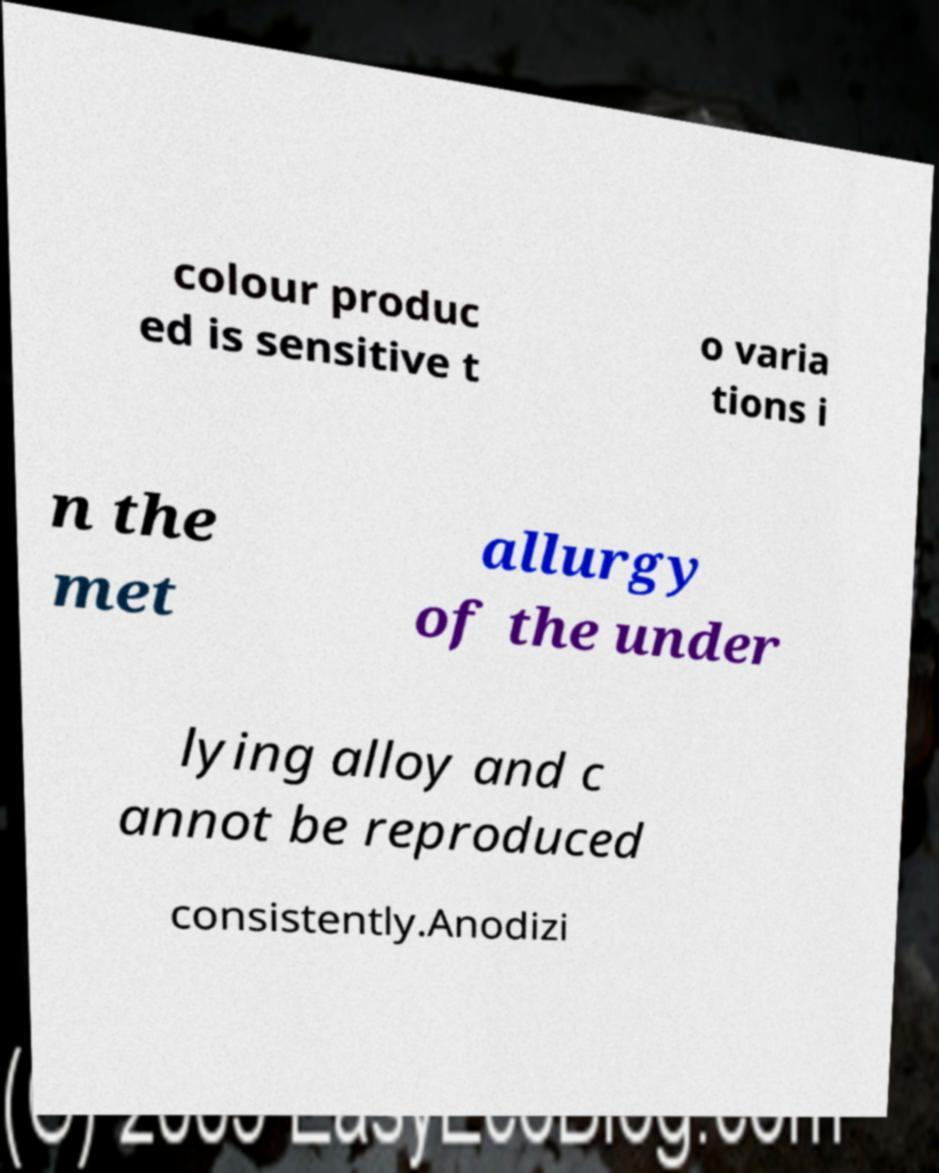Could you assist in decoding the text presented in this image and type it out clearly? colour produc ed is sensitive t o varia tions i n the met allurgy of the under lying alloy and c annot be reproduced consistently.Anodizi 